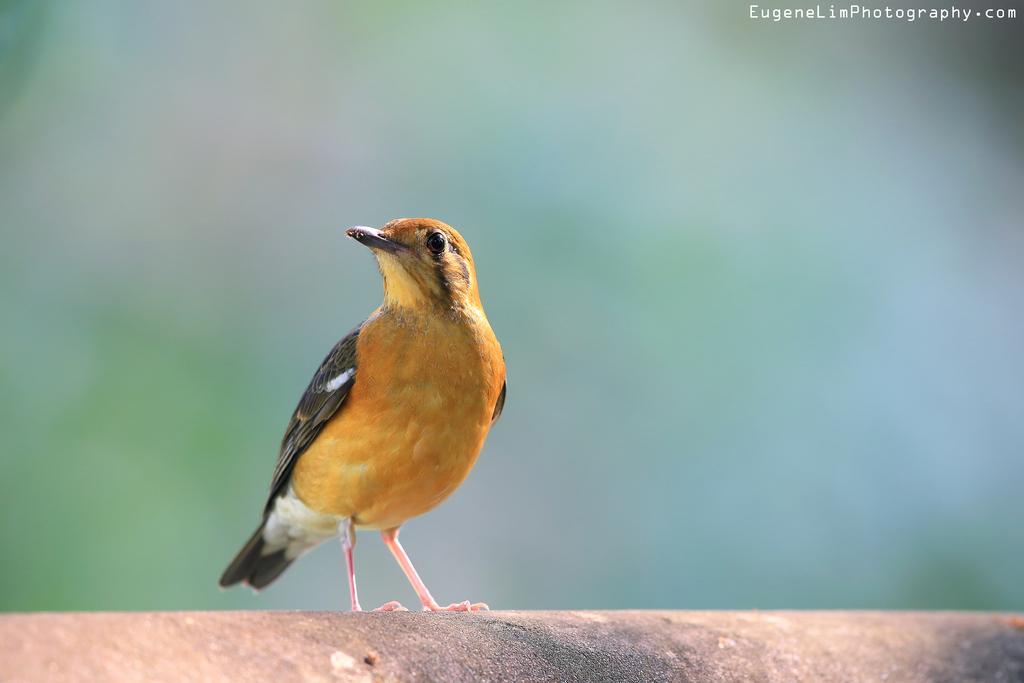In one or two sentences, can you explain what this image depicts? In this we can see a bird on the path and behind the bird there is a blurred background. On the image there is a watermark. 